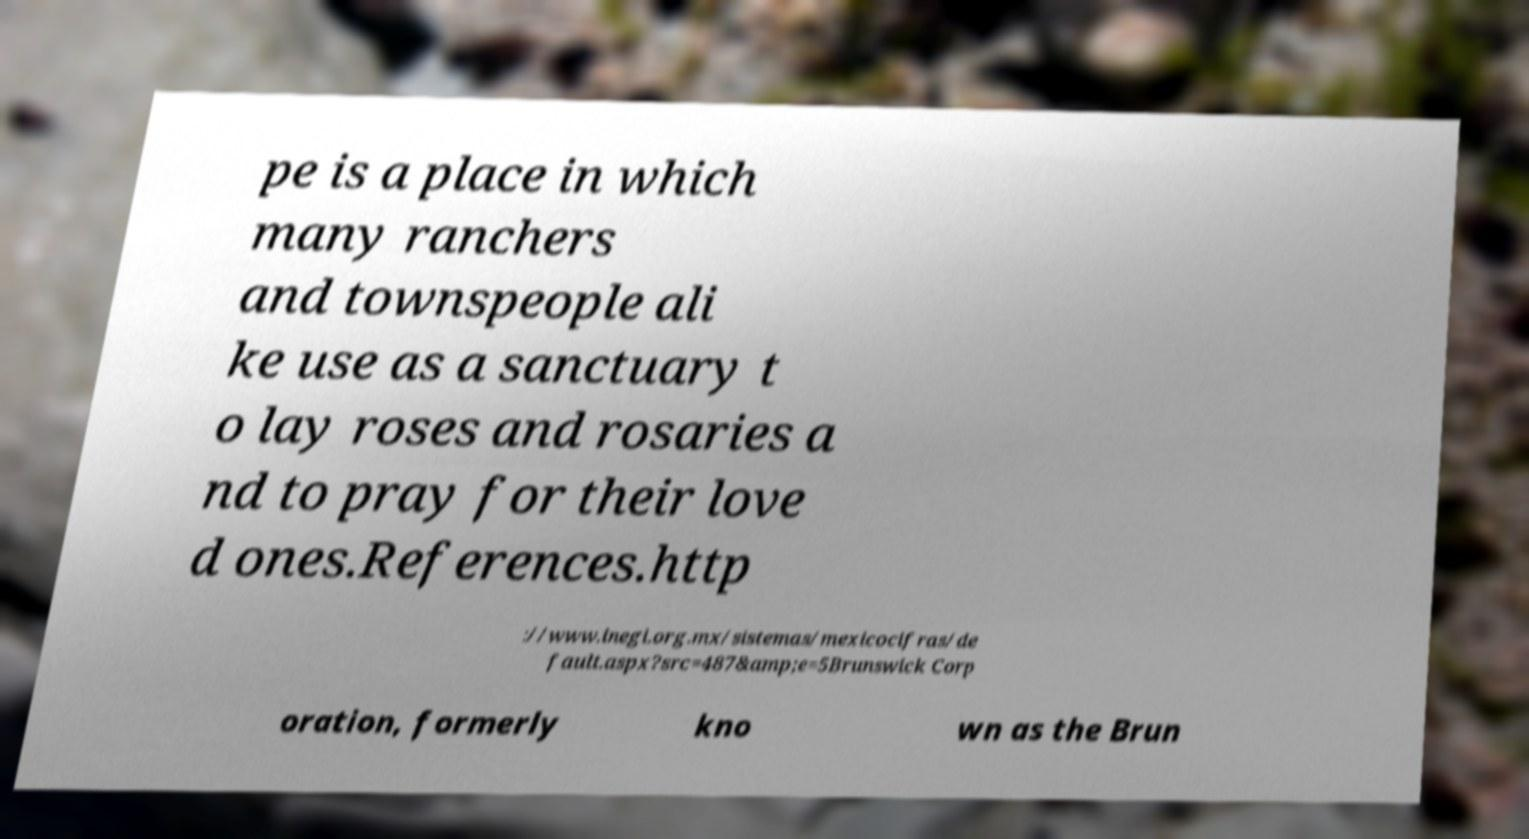There's text embedded in this image that I need extracted. Can you transcribe it verbatim? pe is a place in which many ranchers and townspeople ali ke use as a sanctuary t o lay roses and rosaries a nd to pray for their love d ones.References.http ://www.inegi.org.mx/sistemas/mexicocifras/de fault.aspx?src=487&amp;e=5Brunswick Corp oration, formerly kno wn as the Brun 